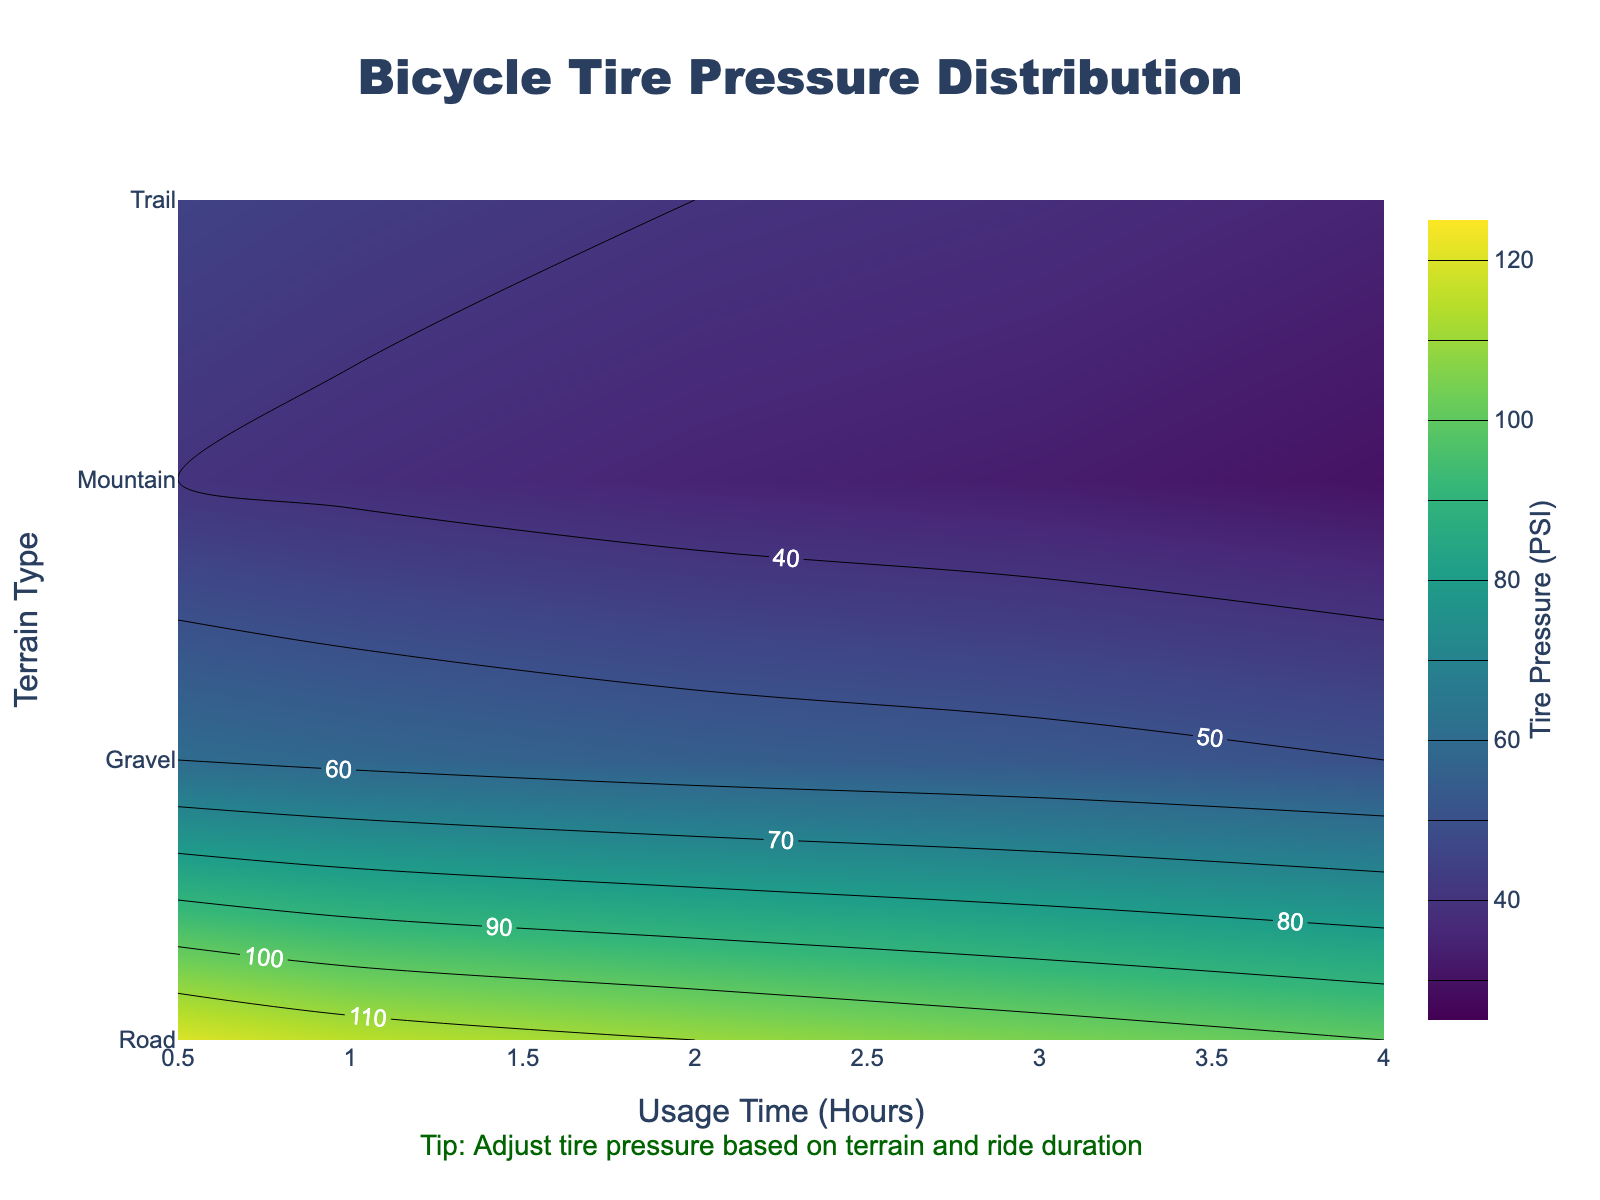What is the title of the figure? The title is clearly displayed at the top center of the plot. It is presented in a larger, bold font to make it stand out.
Answer: Bicycle Tire Pressure Distribution What is the terrain type with the highest initial tire pressure? The contour plot color scheme helps to identify the highest values. The 'Road' terrain type has the highest initial tire pressure value of 120 PSI at the 0.5-hour usage time.
Answer: Road How does tire pressure change over time for mountain terrain? Follow the contour lines corresponding to the 'Mountain' row from left to right. The initial pressure starts at 40 PSI and decreases steadily over time, reaching 30 PSI at 4 hours.
Answer: It decreases Which terrain type shows the most significant drop in tire pressure after 4 hours? A quick scan of the tire pressure values at 4 hours usage shows that 'Road' terrain decreases from 120 PSI to 100 PSI (-20), 'Gravel' from 60 PSI to 50 PSI (-10), 'Mountain' from 40 PSI to 30 PSI (-10), and 'Trail' from 45 PSI to 35 PSI (-10). So, Road's drop is the largest.
Answer: Road From 1 hour to 2 hours of usage, which terrain type experiences a sharp decline in tire pressure and by how much? Check the contour intervals between 1 and 2 hours for each terrain. The Road terrain decreases from 115 PSI to 110 PSI (-5), Gravel from 58 PSI to 55 PSI (-3), Mountain from 38 PSI to 35 PSI (-3), and Trail from 43 PSI to 40 PSI (-3). Road experiences the sharpest decline of 5 PSI.
Answer: Road by 5 PSI For which terrain types does the tire pressure drop below 40 PSI after any period of usage time? Look for parts of the contour plot where the PSI value is 40 or less. Both Mountain and Trail terrains show tire pressures dropping below 40 PSI, while Road and Gravel do not.
Answer: Mountain and Trail Which terrain's tire pressure holds the steadiest over the usage time? Compare the steepness and size of gaps in contour lines over time. The 'Gravel' terrain shows the smallest variation from 60 PSI to 50 PSI over 4 hours, indicating it holds steady relative to other terrains.
Answer: Gravel What are the pressure differences for the 'Road' terrain between 0.5 hours and 4 hours? Identify the pressure values at 0.5 and 4 hours for Road terrain. Subtract the value at 4 hours from the value at 0.5 hours: 120 PSI (0.5 hrs) - 100 PSI (4 hrs) = 20 PSI.
Answer: 20 PSI Which terrain type requires the lowest initial tire pressure? At 0.5 hours, compare the initial tire pressures across all terrains. 'Mountain' requires only 40 PSI, which is the lowest.
Answer: Mountain Is there any terrain where the tire pressure does not consistently decrease with usage time? Observe the progression of tire pressure values over time for each terrain. Though values decrease consistently overall, 'Gravel' terrain has the smallest and most consistent decreases. No terrain shows inconsistent trends.
Answer: No 